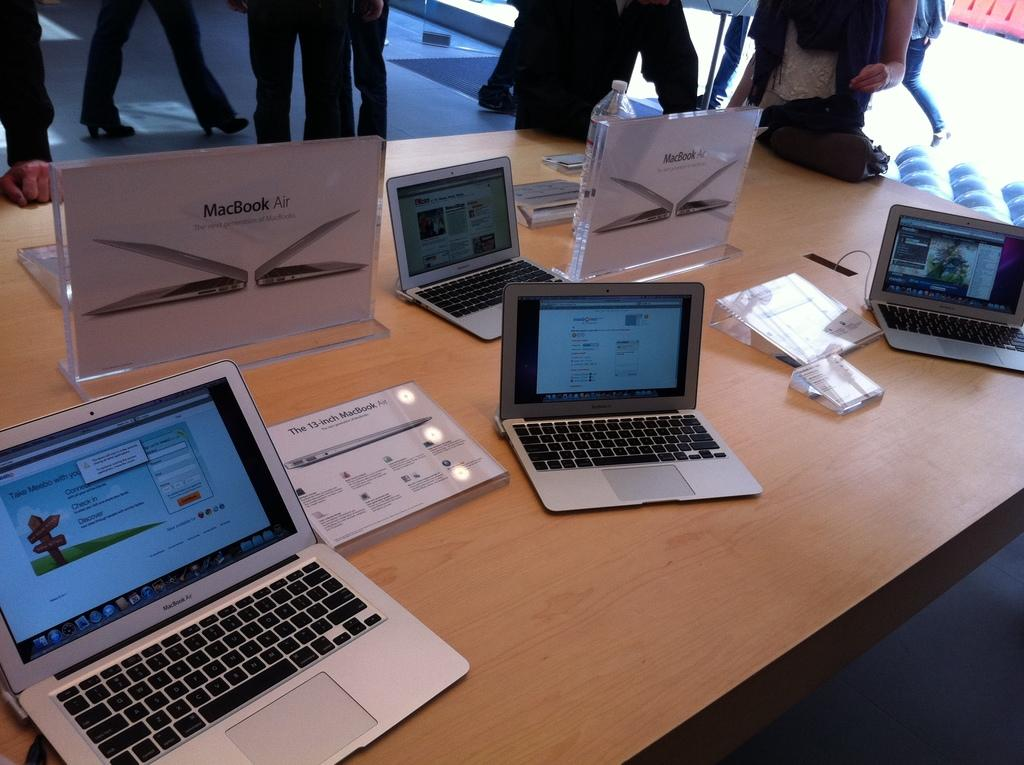<image>
Give a short and clear explanation of the subsequent image. A group of laptops that are advertised as MacBook air's. 